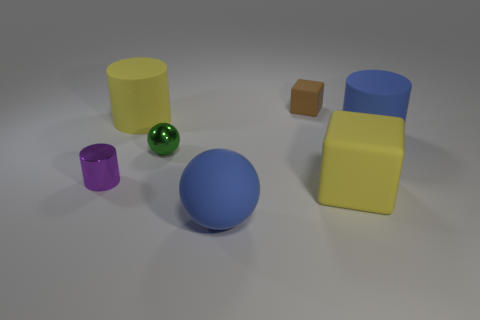How many small objects are behind the big cylinder to the right of the rubber thing that is left of the tiny shiny sphere?
Provide a short and direct response. 1. Do the large rubber sphere and the big cylinder to the right of the tiny brown rubber cube have the same color?
Ensure brevity in your answer.  Yes. There is a cylinder that is made of the same material as the tiny green thing; what size is it?
Provide a succinct answer. Small. Are there more small purple metal things that are in front of the small brown cube than cyan matte cylinders?
Ensure brevity in your answer.  Yes. What material is the sphere that is behind the big blue matte object in front of the tiny thing that is to the left of the green metallic ball?
Ensure brevity in your answer.  Metal. Do the blue cylinder and the ball behind the purple shiny thing have the same material?
Provide a short and direct response. No. What material is the yellow object that is the same shape as the brown thing?
Provide a short and direct response. Rubber. Is there anything else that has the same material as the brown block?
Your answer should be compact. Yes. Are there more small metal things that are on the left side of the large yellow matte cylinder than yellow cubes behind the tiny green metallic sphere?
Make the answer very short. Yes. There is a big yellow object that is made of the same material as the big block; what shape is it?
Keep it short and to the point. Cylinder. 